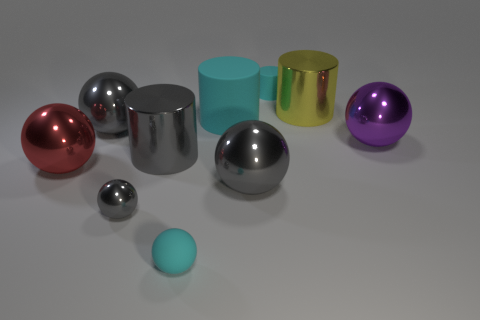How many gray spheres must be subtracted to get 1 gray spheres? 2 Subtract all blue blocks. How many gray balls are left? 3 Subtract all large yellow cylinders. How many cylinders are left? 3 Subtract all purple balls. How many balls are left? 5 Subtract all purple cylinders. Subtract all cyan cubes. How many cylinders are left? 4 Subtract all spheres. How many objects are left? 4 Add 7 big yellow metal cylinders. How many big yellow metal cylinders exist? 8 Subtract 0 brown cylinders. How many objects are left? 10 Subtract all tiny cylinders. Subtract all purple metallic objects. How many objects are left? 8 Add 1 red spheres. How many red spheres are left? 2 